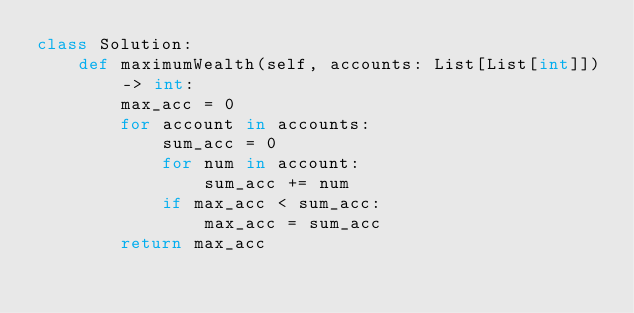<code> <loc_0><loc_0><loc_500><loc_500><_Python_>class Solution:
    def maximumWealth(self, accounts: List[List[int]]) -> int:
        max_acc = 0
        for account in accounts:
            sum_acc = 0
            for num in account:
                sum_acc += num
            if max_acc < sum_acc:
                max_acc = sum_acc
        return max_acc</code> 